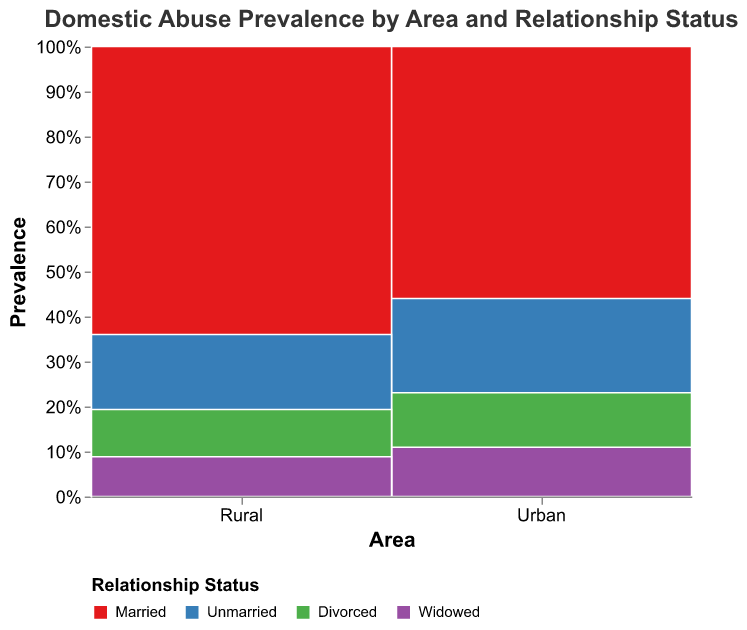What is the title of the plot? The title of the plot is located at the top of the figure. It provides a clear indication of the visualized data.
Answer: Domestic Abuse Prevalence by Area and Relationship Status What are the two main areas compared in this plot? The two main areas compared in the plot are listed under the 'Area' axis at the bottom of the figure.
Answer: Urban and Rural Which relationship status has the highest prevalence of domestic abuse in rural areas? Within the 'Rural' area, each relationship status is represented by a different color. The highest prevalence has the longest corresponding rectangle on the y-axis.
Answer: Married What percentage of the total prevalence in urban areas is for divorced individuals? The height of the section for divorced individuals in the urban area compared to the total height of the urban column shows the required percentage.
Answer: 15% Is the prevalence of domestic abuse higher for married individuals in urban or rural areas? By comparing the 'Married' sections (in red) of both 'Urban' and 'Rural' areas, we can see which one is higher.
Answer: Rural Considering both areas, which relationship status experiences the lowest total prevalence of domestic abuse? By comparing the total heights of all relationship statuses in both 'Urban' and 'Rural' areas, the lowest one can be identified.
Answer: Widowed What is the difference in domestic abuse prevalence between urban and rural unmarried individuals? Find the sections representing 'Unmarried' in both 'Urban' and 'Rural' areas and subtract the smaller value from the larger value.
Answer: 4 What is the combined prevalence of domestic abuse for widowed individuals in both areas? Sum the prevalence values for 'Widowed' in both 'Urban' and 'Rural' areas.
Answer: 14 Which area has a more diverse distribution of domestic abuse prevalence across different relationship statuses? Comparing the distribution in 'Urban' and 'Rural' areas, evaluate which has more equal proportions across all statuses.
Answer: Urban How does the prevalence of domestic abuse for divorced individuals compare between urban and rural areas? Compare the sections for 'Divorced' in both 'Urban' and 'Rural' areas and determine if one is greater than, less than, or equal to the other.
Answer: Urban > Rural 